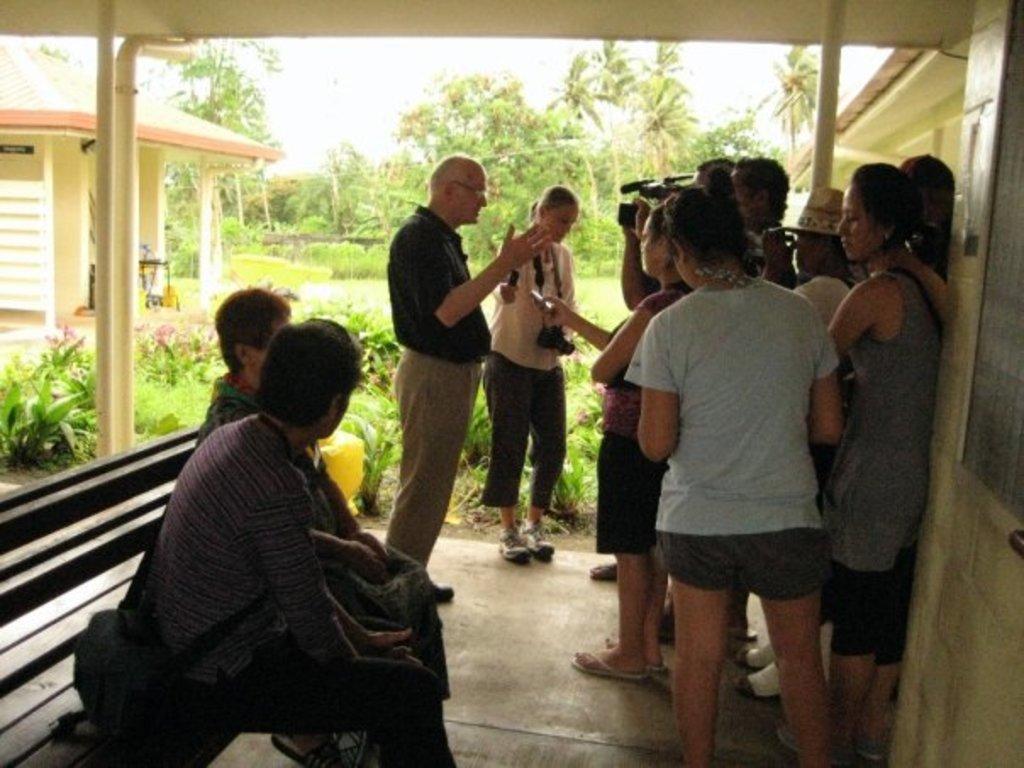Could you give a brief overview of what you see in this image? In this picture I can see couple of houses and few people are standing and I can see a man holding a camera and a microphone in one hand and I can see couple of them sitting on the bench and I can see trees, plants and a cloudy sky. 